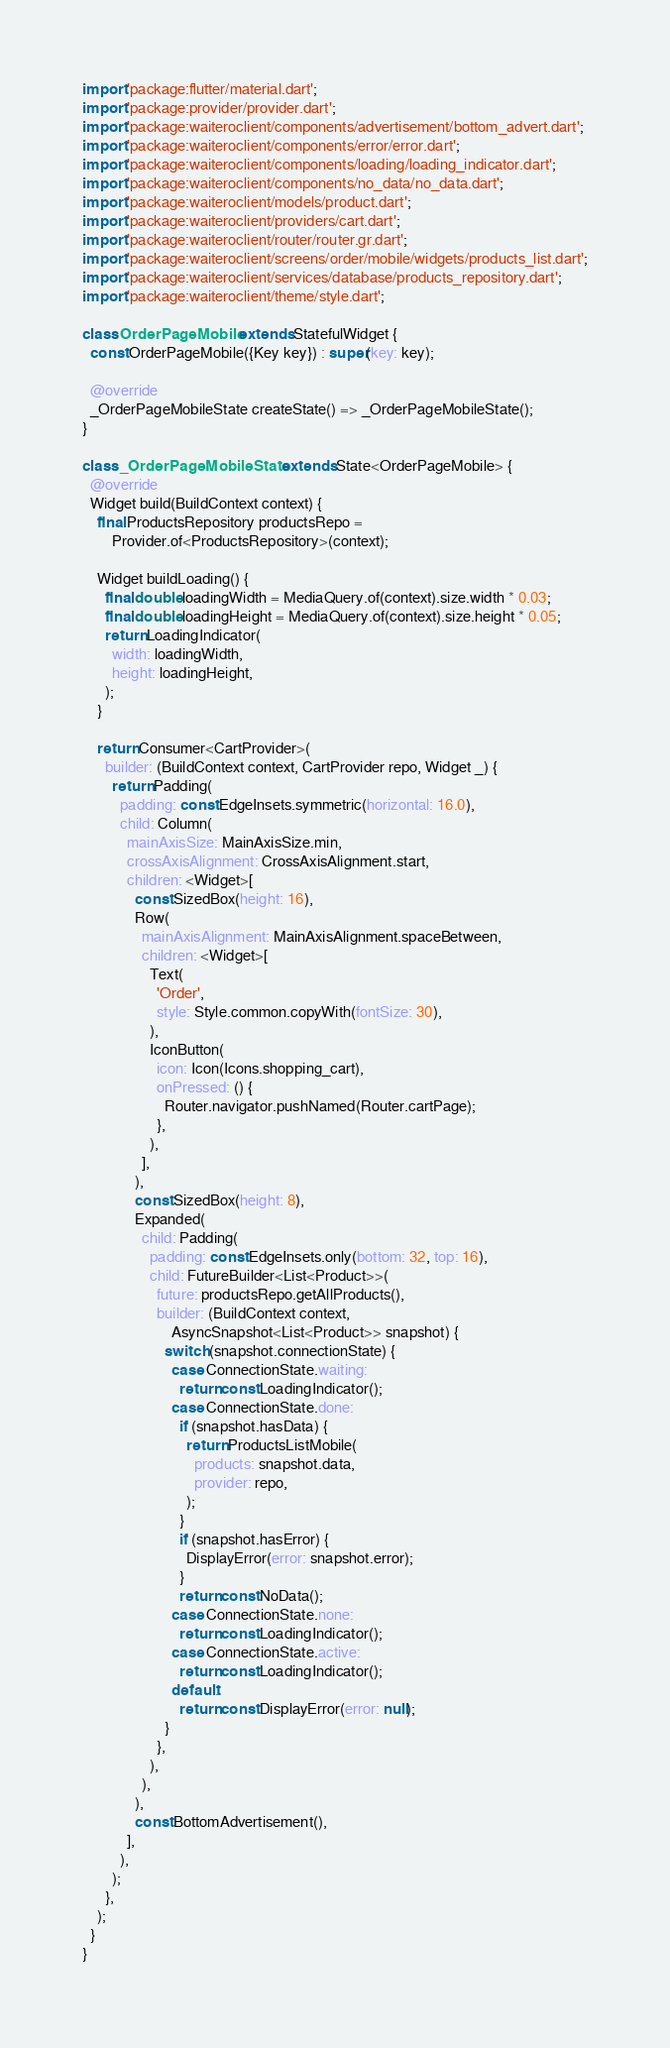Convert code to text. <code><loc_0><loc_0><loc_500><loc_500><_Dart_>import 'package:flutter/material.dart';
import 'package:provider/provider.dart';
import 'package:waiteroclient/components/advertisement/bottom_advert.dart';
import 'package:waiteroclient/components/error/error.dart';
import 'package:waiteroclient/components/loading/loading_indicator.dart';
import 'package:waiteroclient/components/no_data/no_data.dart';
import 'package:waiteroclient/models/product.dart';
import 'package:waiteroclient/providers/cart.dart';
import 'package:waiteroclient/router/router.gr.dart';
import 'package:waiteroclient/screens/order/mobile/widgets/products_list.dart';
import 'package:waiteroclient/services/database/products_repository.dart';
import 'package:waiteroclient/theme/style.dart';

class OrderPageMobile extends StatefulWidget {
  const OrderPageMobile({Key key}) : super(key: key);

  @override
  _OrderPageMobileState createState() => _OrderPageMobileState();
}

class _OrderPageMobileState extends State<OrderPageMobile> {
  @override
  Widget build(BuildContext context) {
    final ProductsRepository productsRepo =
        Provider.of<ProductsRepository>(context);

    Widget buildLoading() {
      final double loadingWidth = MediaQuery.of(context).size.width * 0.03;
      final double loadingHeight = MediaQuery.of(context).size.height * 0.05;
      return LoadingIndicator(
        width: loadingWidth,
        height: loadingHeight,
      );
    }

    return Consumer<CartProvider>(
      builder: (BuildContext context, CartProvider repo, Widget _) {
        return Padding(
          padding: const EdgeInsets.symmetric(horizontal: 16.0),
          child: Column(
            mainAxisSize: MainAxisSize.min,
            crossAxisAlignment: CrossAxisAlignment.start,
            children: <Widget>[
              const SizedBox(height: 16),
              Row(
                mainAxisAlignment: MainAxisAlignment.spaceBetween,
                children: <Widget>[
                  Text(
                    'Order',
                    style: Style.common.copyWith(fontSize: 30),
                  ),
                  IconButton(
                    icon: Icon(Icons.shopping_cart),
                    onPressed: () {
                      Router.navigator.pushNamed(Router.cartPage);
                    },
                  ),
                ],
              ),
              const SizedBox(height: 8),
              Expanded(
                child: Padding(
                  padding: const EdgeInsets.only(bottom: 32, top: 16),
                  child: FutureBuilder<List<Product>>(
                    future: productsRepo.getAllProducts(),
                    builder: (BuildContext context,
                        AsyncSnapshot<List<Product>> snapshot) {
                      switch (snapshot.connectionState) {
                        case ConnectionState.waiting:
                          return const LoadingIndicator();
                        case ConnectionState.done:
                          if (snapshot.hasData) {
                            return ProductsListMobile(
                              products: snapshot.data,
                              provider: repo,
                            );
                          }
                          if (snapshot.hasError) {
                            DisplayError(error: snapshot.error);
                          }
                          return const NoData();
                        case ConnectionState.none:
                          return const LoadingIndicator();
                        case ConnectionState.active:
                          return const LoadingIndicator();
                        default:
                          return const DisplayError(error: null);
                      }
                    },
                  ),
                ),
              ),
              const BottomAdvertisement(),
            ],
          ),
        );
      },
    );
  }
}
</code> 